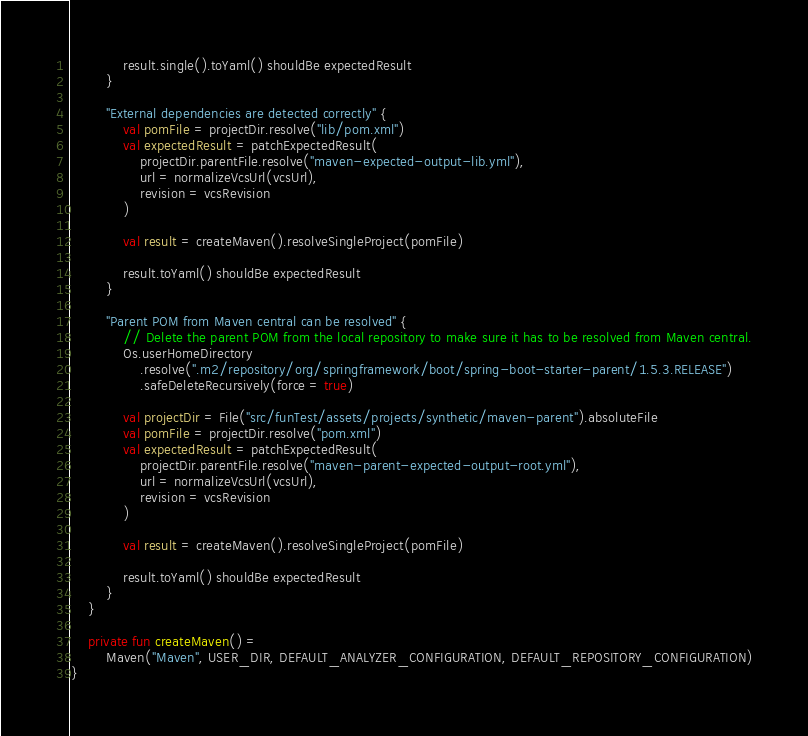<code> <loc_0><loc_0><loc_500><loc_500><_Kotlin_>            result.single().toYaml() shouldBe expectedResult
        }

        "External dependencies are detected correctly" {
            val pomFile = projectDir.resolve("lib/pom.xml")
            val expectedResult = patchExpectedResult(
                projectDir.parentFile.resolve("maven-expected-output-lib.yml"),
                url = normalizeVcsUrl(vcsUrl),
                revision = vcsRevision
            )

            val result = createMaven().resolveSingleProject(pomFile)

            result.toYaml() shouldBe expectedResult
        }

        "Parent POM from Maven central can be resolved" {
            // Delete the parent POM from the local repository to make sure it has to be resolved from Maven central.
            Os.userHomeDirectory
                .resolve(".m2/repository/org/springframework/boot/spring-boot-starter-parent/1.5.3.RELEASE")
                .safeDeleteRecursively(force = true)

            val projectDir = File("src/funTest/assets/projects/synthetic/maven-parent").absoluteFile
            val pomFile = projectDir.resolve("pom.xml")
            val expectedResult = patchExpectedResult(
                projectDir.parentFile.resolve("maven-parent-expected-output-root.yml"),
                url = normalizeVcsUrl(vcsUrl),
                revision = vcsRevision
            )

            val result = createMaven().resolveSingleProject(pomFile)

            result.toYaml() shouldBe expectedResult
        }
    }

    private fun createMaven() =
        Maven("Maven", USER_DIR, DEFAULT_ANALYZER_CONFIGURATION, DEFAULT_REPOSITORY_CONFIGURATION)
}
</code> 